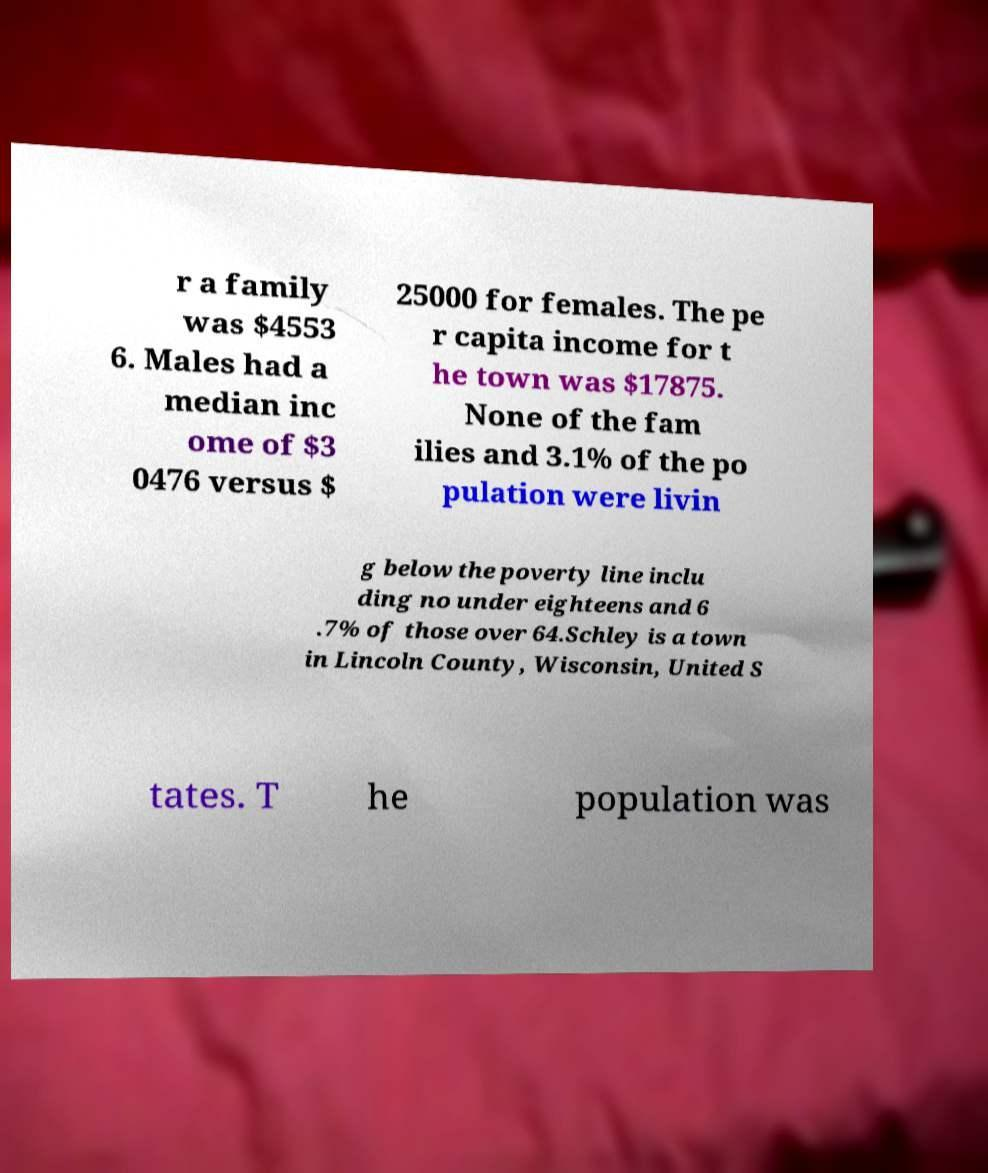For documentation purposes, I need the text within this image transcribed. Could you provide that? r a family was $4553 6. Males had a median inc ome of $3 0476 versus $ 25000 for females. The pe r capita income for t he town was $17875. None of the fam ilies and 3.1% of the po pulation were livin g below the poverty line inclu ding no under eighteens and 6 .7% of those over 64.Schley is a town in Lincoln County, Wisconsin, United S tates. T he population was 